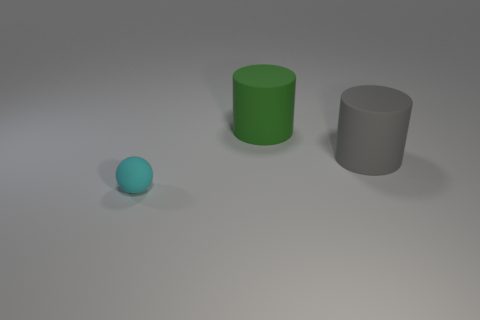How many big matte things have the same color as the small ball?
Your answer should be compact. 0. The other rubber thing that is the same size as the green matte object is what shape?
Your answer should be compact. Cylinder. Is there a large thing of the same shape as the small cyan thing?
Offer a terse response. No. How many large gray things are made of the same material as the tiny cyan sphere?
Keep it short and to the point. 1. Is the tiny cyan object left of the green rubber cylinder made of the same material as the big green cylinder?
Your response must be concise. Yes. Are there more large green matte cylinders left of the cyan rubber object than small objects that are in front of the big gray object?
Offer a very short reply. No. What material is the thing that is the same size as the gray cylinder?
Give a very brief answer. Rubber. How many other things are the same material as the green cylinder?
Give a very brief answer. 2. There is a big matte object that is left of the gray rubber thing; does it have the same shape as the cyan object in front of the big green rubber cylinder?
Provide a short and direct response. No. How many other objects are the same color as the ball?
Ensure brevity in your answer.  0. 